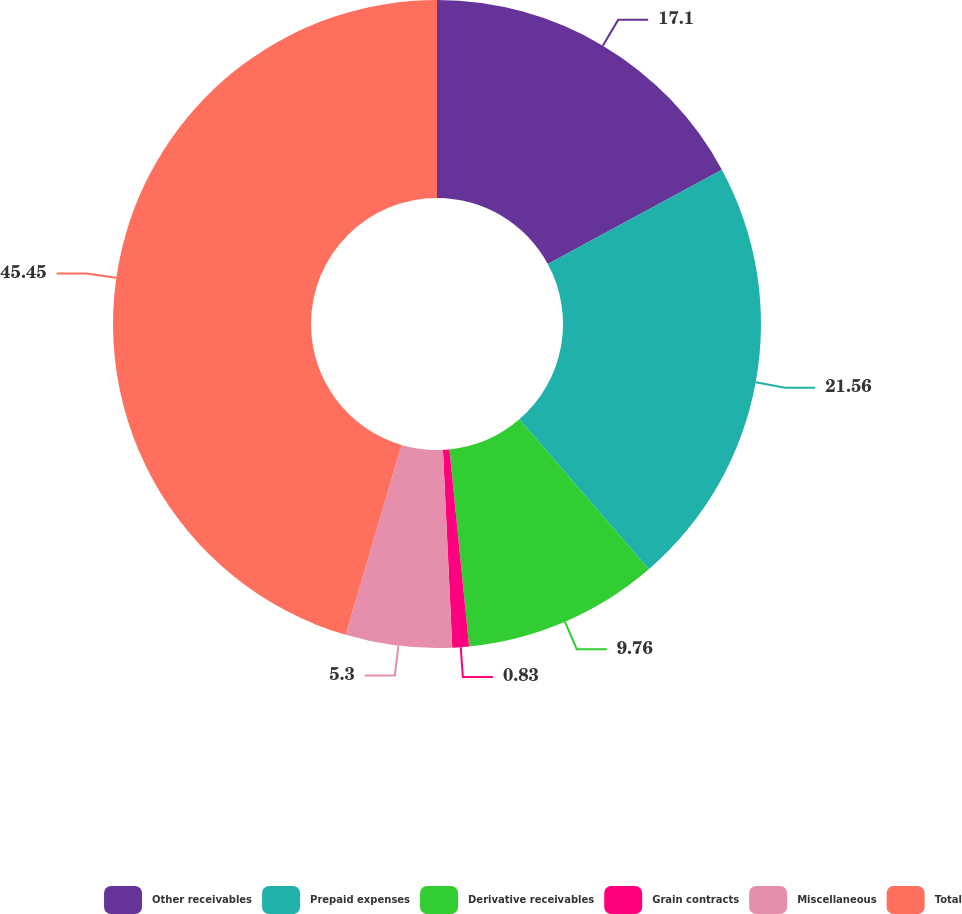Convert chart. <chart><loc_0><loc_0><loc_500><loc_500><pie_chart><fcel>Other receivables<fcel>Prepaid expenses<fcel>Derivative receivables<fcel>Grain contracts<fcel>Miscellaneous<fcel>Total<nl><fcel>17.1%<fcel>21.56%<fcel>9.76%<fcel>0.83%<fcel>5.3%<fcel>45.45%<nl></chart> 